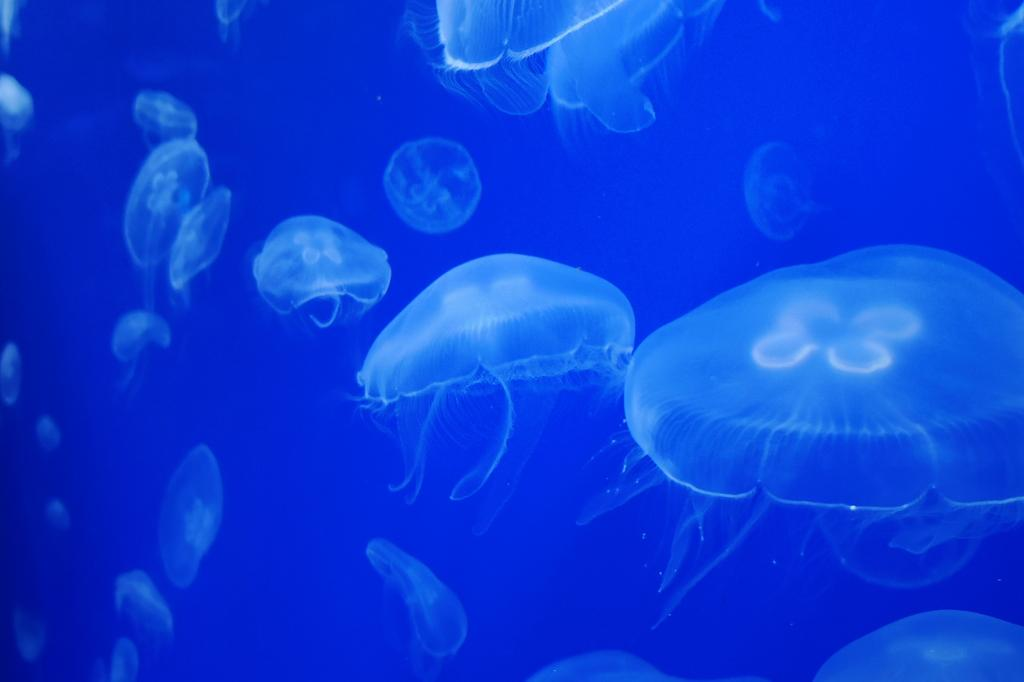What type of animals are in the image? There are jellyfishes in the image. Where are the jellyfishes located? The jellyfishes are in water. What type of bird is flying in the group with the wren in the image? There is no bird or wren present in the image; it features jellyfishes in water. 